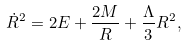Convert formula to latex. <formula><loc_0><loc_0><loc_500><loc_500>\dot { R } ^ { 2 } = 2 E + \frac { 2 M } { R } + \frac { \Lambda } { 3 } R ^ { 2 } ,</formula> 